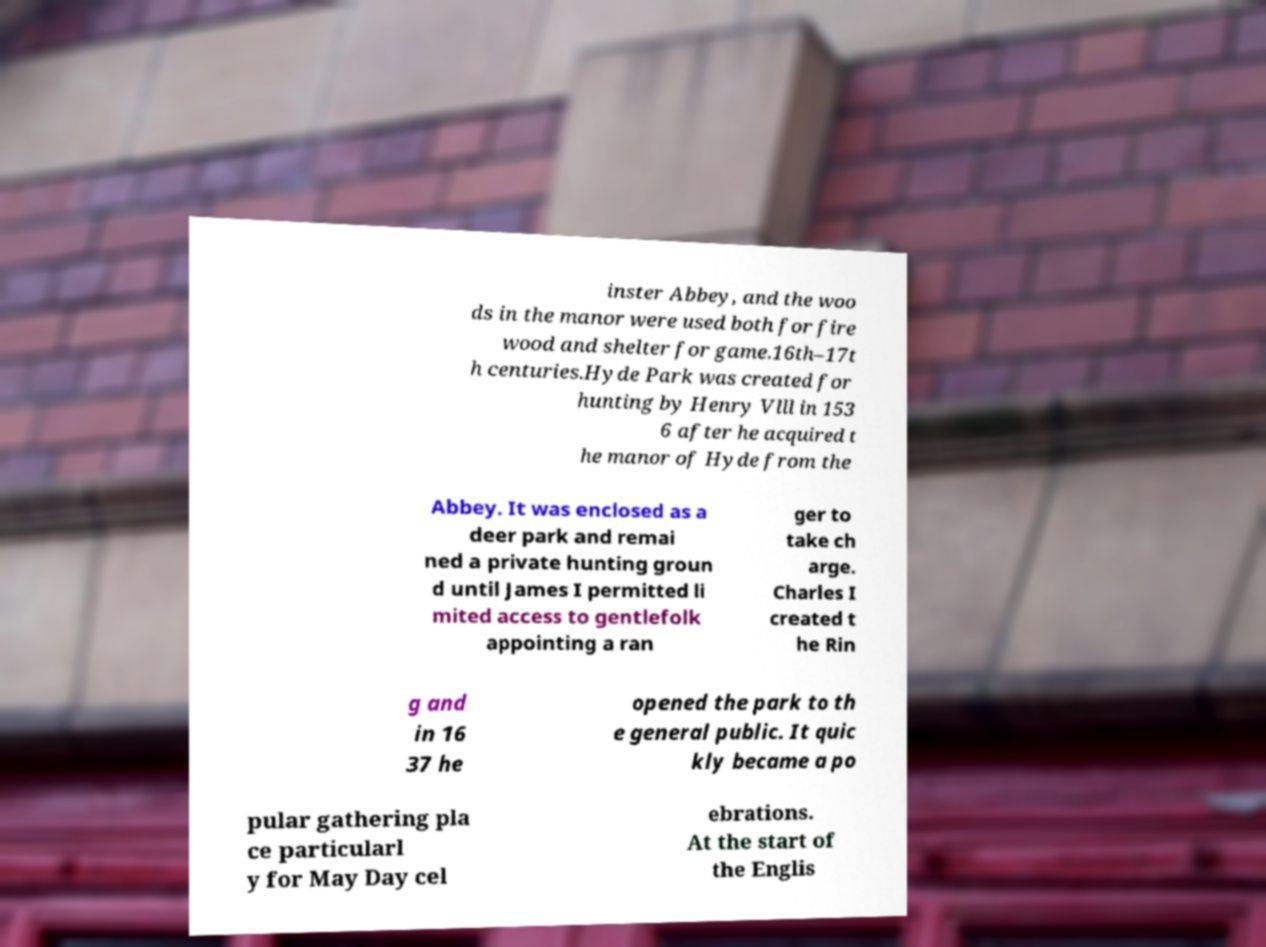What messages or text are displayed in this image? I need them in a readable, typed format. inster Abbey, and the woo ds in the manor were used both for fire wood and shelter for game.16th–17t h centuries.Hyde Park was created for hunting by Henry Vlll in 153 6 after he acquired t he manor of Hyde from the Abbey. It was enclosed as a deer park and remai ned a private hunting groun d until James I permitted li mited access to gentlefolk appointing a ran ger to take ch arge. Charles I created t he Rin g and in 16 37 he opened the park to th e general public. It quic kly became a po pular gathering pla ce particularl y for May Day cel ebrations. At the start of the Englis 